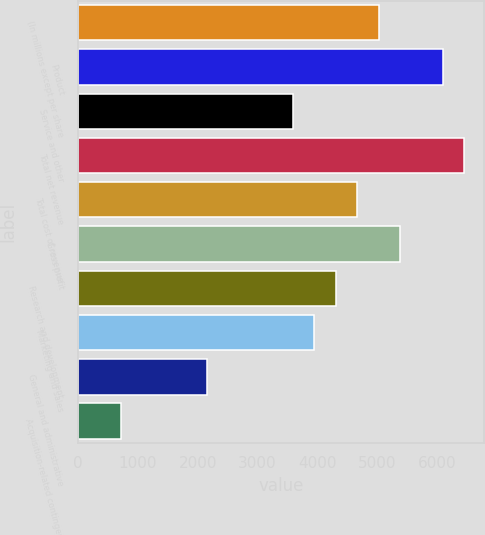Convert chart. <chart><loc_0><loc_0><loc_500><loc_500><bar_chart><fcel>(In millions except per share<fcel>Product<fcel>Service and other<fcel>Total net revenue<fcel>Total cost of revenue<fcel>Gross profit<fcel>Research and development<fcel>Marketing and sales<fcel>General and administrative<fcel>Acquisition-related contingent<nl><fcel>5023.4<fcel>6099.2<fcel>3589<fcel>6457.8<fcel>4664.8<fcel>5382<fcel>4306.2<fcel>3947.6<fcel>2154.6<fcel>720.2<nl></chart> 